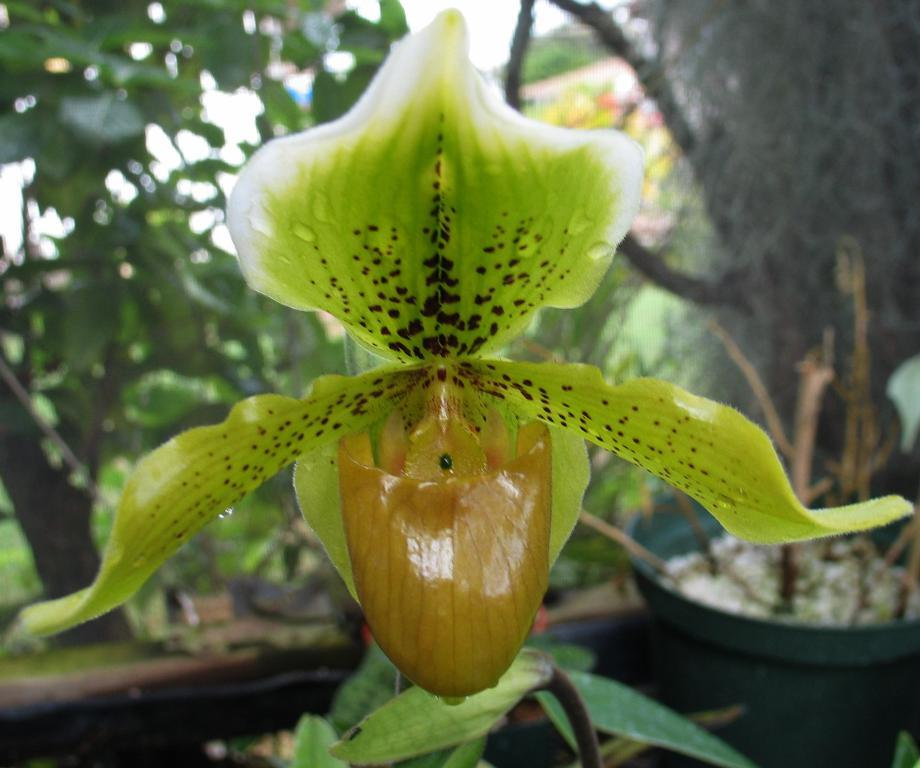What is the main subject in the front of the image? There is a green flower in the front of the image. What else can be seen in the image besides the flower? There are plants visible behind the flower. How would you describe the background of the image? The background of the image is blurred. How many bikes are parked next to the green flower in the image? There are no bikes present in the image; it features a green flower and plants. What type of observation can be made about the green flower in the image? The question is unclear and does not relate to any specific detail about the image. The image only shows a green flower and plants, so it is not possible to make a specific observation about the flower. 